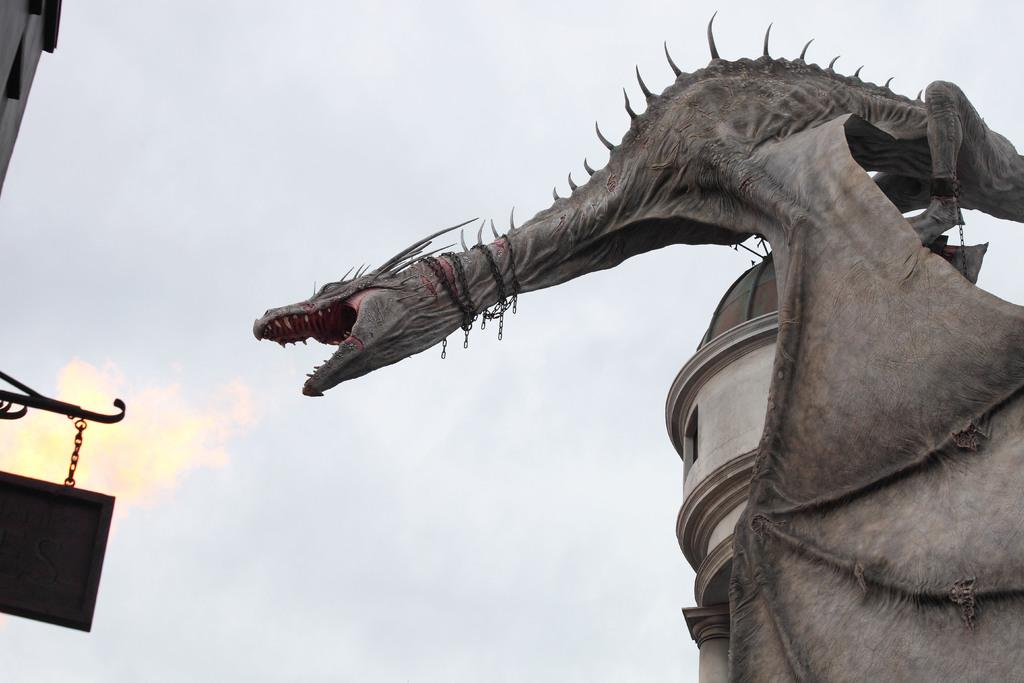What is the main subject of the image? There is a giant sculpture of a dragon in the image. Where is the dragon located? The dragon is sitting on a tower. What can be seen in the background of the image? The sky is visible in the background of the image. What type of apple is the dragon eating in the image? There is no apple present in the image, and the dragon is not depicted as eating anything. 